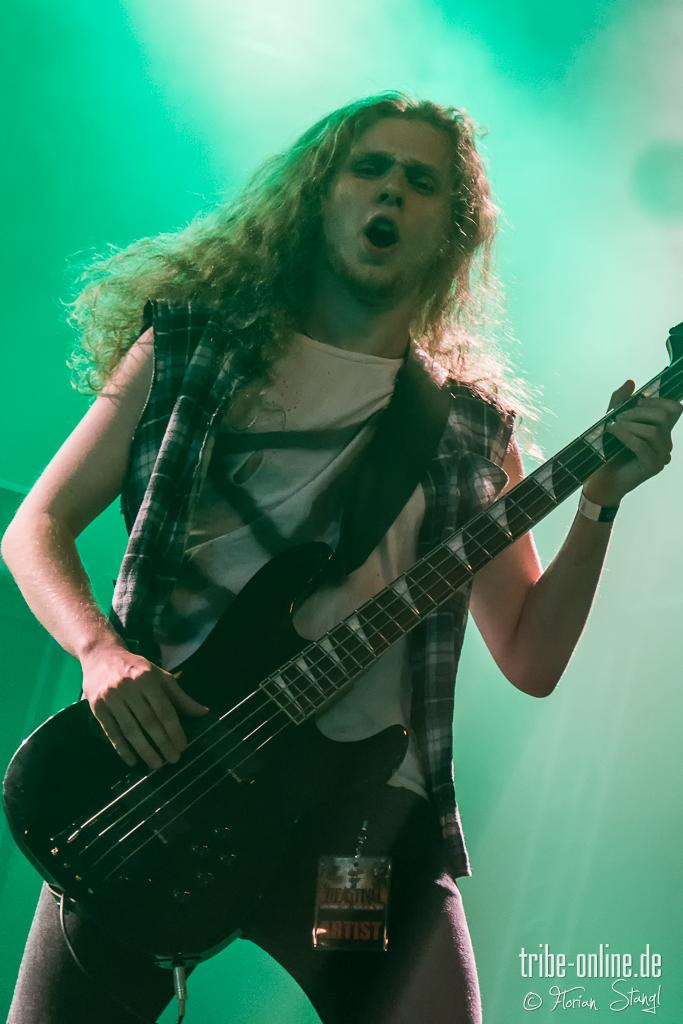What is the person in the image doing? The person is singing and playing a guitar. What instrument is the person playing in the image? The person is playing a guitar. What color is the background in the image? The background in the image is green. What type of pancake is the person flipping in the image? There is no pancake present in the image; the person is singing and playing a guitar. 